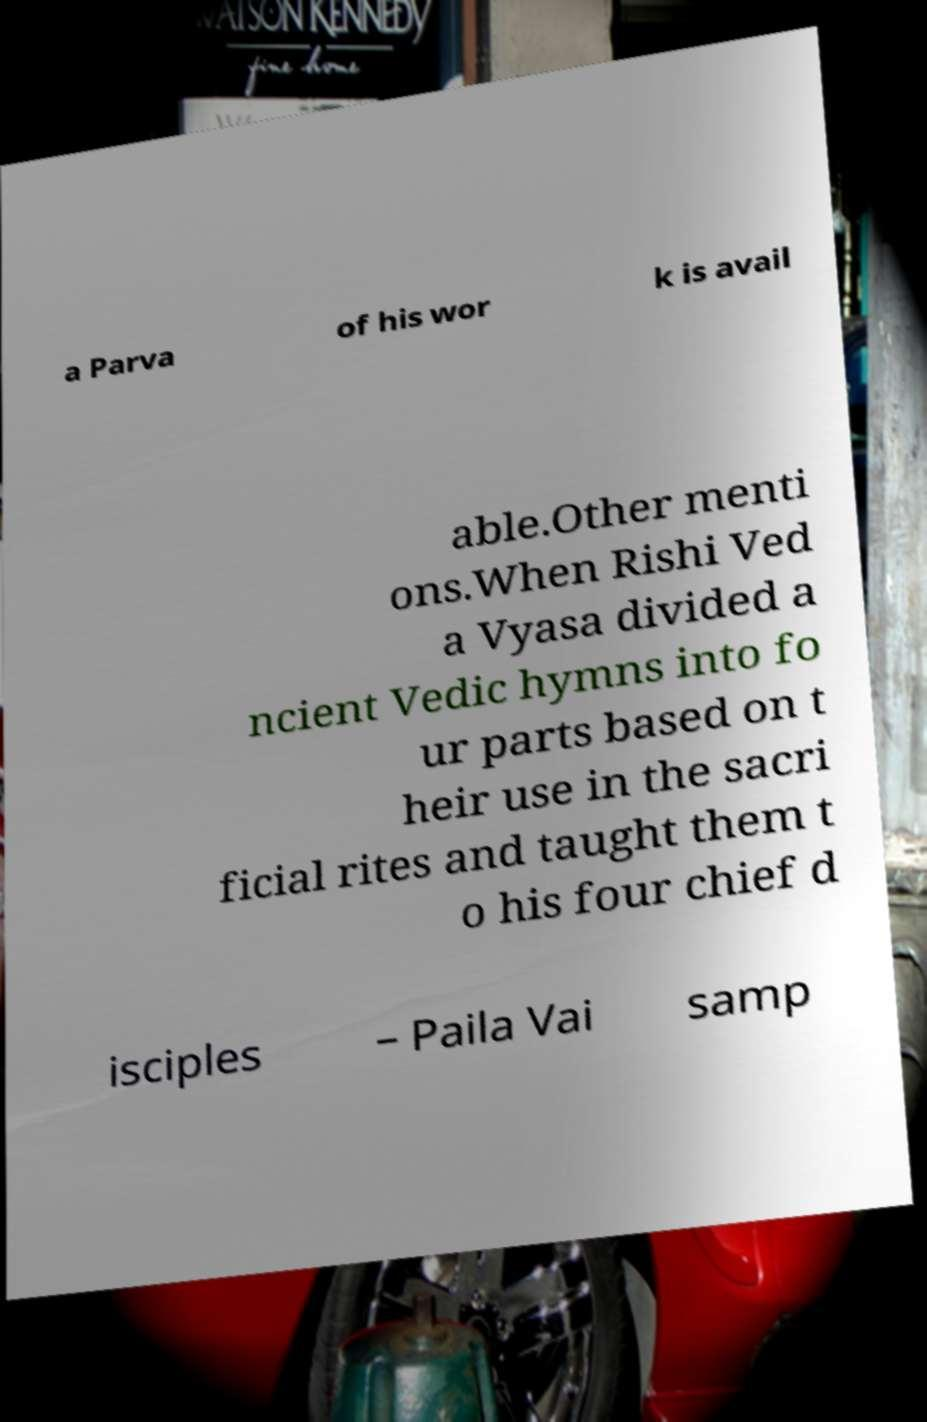Can you accurately transcribe the text from the provided image for me? a Parva of his wor k is avail able.Other menti ons.When Rishi Ved a Vyasa divided a ncient Vedic hymns into fo ur parts based on t heir use in the sacri ficial rites and taught them t o his four chief d isciples – Paila Vai samp 